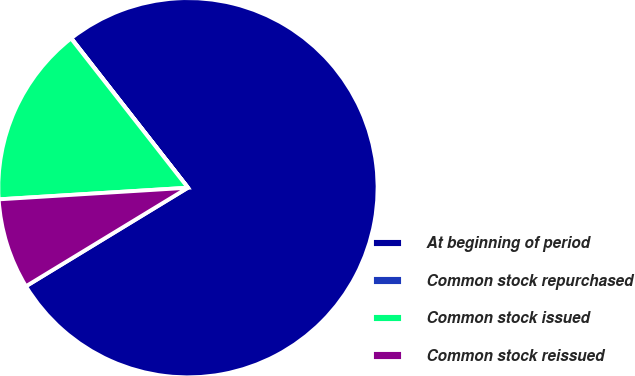Convert chart. <chart><loc_0><loc_0><loc_500><loc_500><pie_chart><fcel>At beginning of period<fcel>Common stock repurchased<fcel>Common stock issued<fcel>Common stock reissued<nl><fcel>76.85%<fcel>0.03%<fcel>15.4%<fcel>7.72%<nl></chart> 